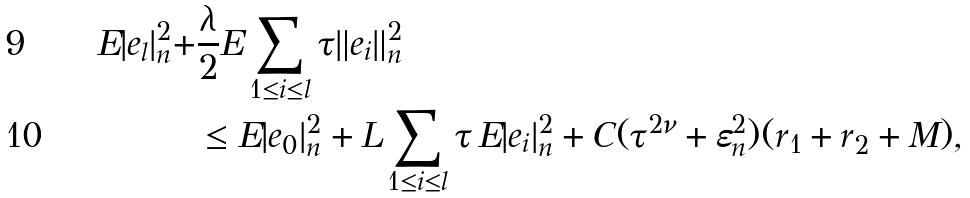Convert formula to latex. <formula><loc_0><loc_0><loc_500><loc_500>E | e _ { l } | _ { n } ^ { 2 } + & \frac { \lambda } { 2 } E \sum _ { 1 \leq i \leq l } \tau \| e _ { i } \| _ { n } ^ { 2 } \\ & \leq E | e _ { 0 } | _ { n } ^ { 2 } + L \sum _ { 1 \leq i \leq l } \tau \, E | e _ { i } | _ { n } ^ { 2 } + C ( \tau ^ { 2 \nu } + \varepsilon _ { n } ^ { 2 } ) ( r _ { 1 } + r _ { 2 } + M ) ,</formula> 